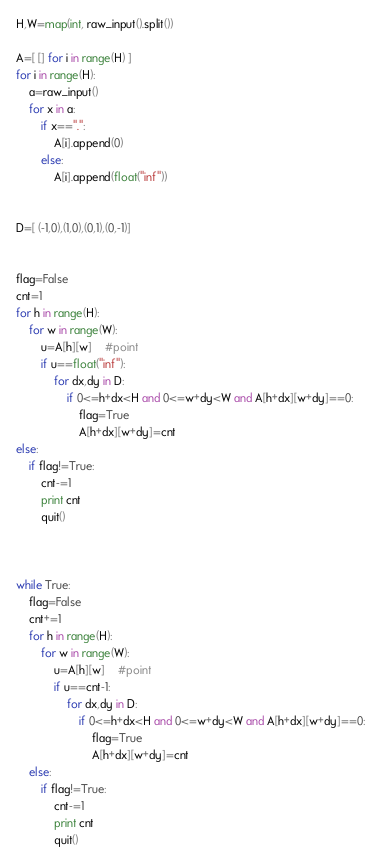Convert code to text. <code><loc_0><loc_0><loc_500><loc_500><_Python_>H,W=map(int, raw_input().split())

A=[ [] for i in range(H) ]
for i in range(H):
	a=raw_input()
	for x in a:
		if x==".":
			A[i].append(0)
		else:
			A[i].append(float("inf"))


D=[ (-1,0),(1,0),(0,1),(0,-1)]


flag=False
cnt=1
for h in range(H):
	for w in range(W):
		u=A[h][w]	#point
		if u==float("inf"):
			for dx,dy in D:
				if 0<=h+dx<H and 0<=w+dy<W and A[h+dx][w+dy]==0:
					flag=True
					A[h+dx][w+dy]=cnt
else:
	if flag!=True:
		cnt-=1
		print cnt
		quit()



while True:
	flag=False
	cnt+=1
	for h in range(H):
		for w in range(W):
			u=A[h][w]	#point
			if u==cnt-1:
				for dx,dy in D:
					if 0<=h+dx<H and 0<=w+dy<W and A[h+dx][w+dy]==0:
						flag=True
						A[h+dx][w+dy]=cnt
	else:
		if flag!=True:
			cnt-=1
			print cnt
			quit()

</code> 